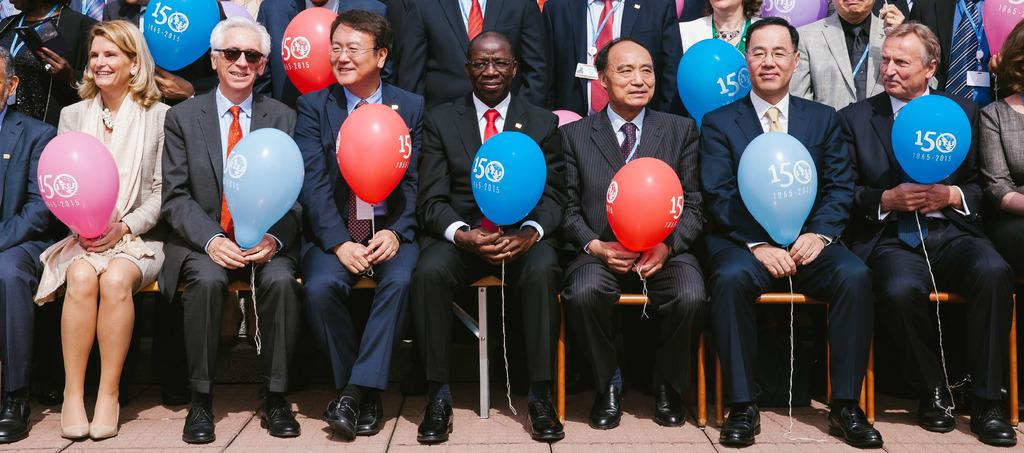Who or what can be seen in the image? There are people in the image. What are some of the people holding? Some people are holding balloons. What can be seen beneath the people in the image? The ground is visible in the image. What type of acoustics can be heard in the image? There is no information about acoustics or sounds in the image, so it cannot be determined from the image. 